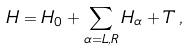<formula> <loc_0><loc_0><loc_500><loc_500>H = H _ { 0 } + \sum _ { \alpha = L , R } H _ { \alpha } + T \, ,</formula> 